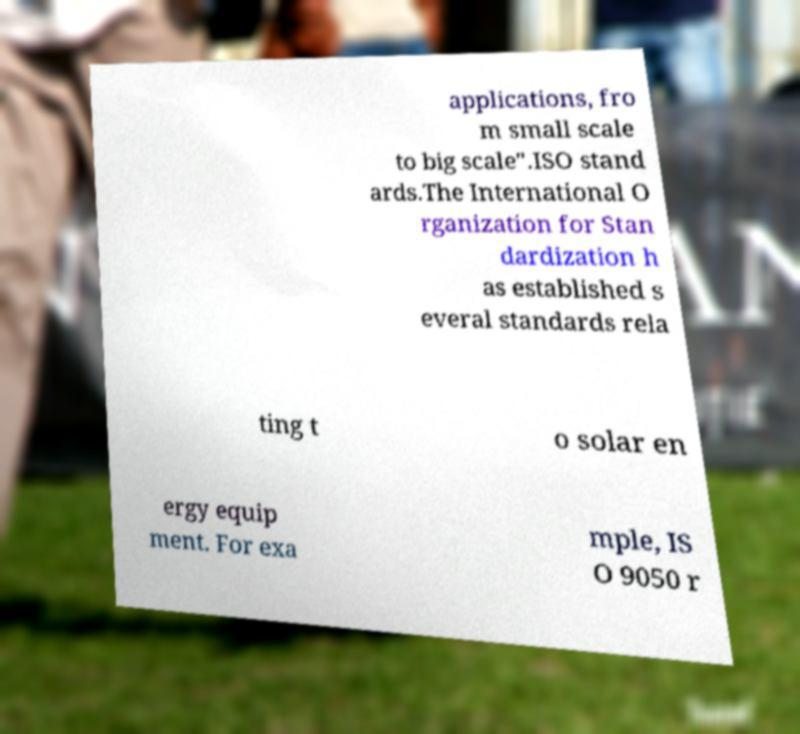Could you assist in decoding the text presented in this image and type it out clearly? applications, fro m small scale to big scale".ISO stand ards.The International O rganization for Stan dardization h as established s everal standards rela ting t o solar en ergy equip ment. For exa mple, IS O 9050 r 